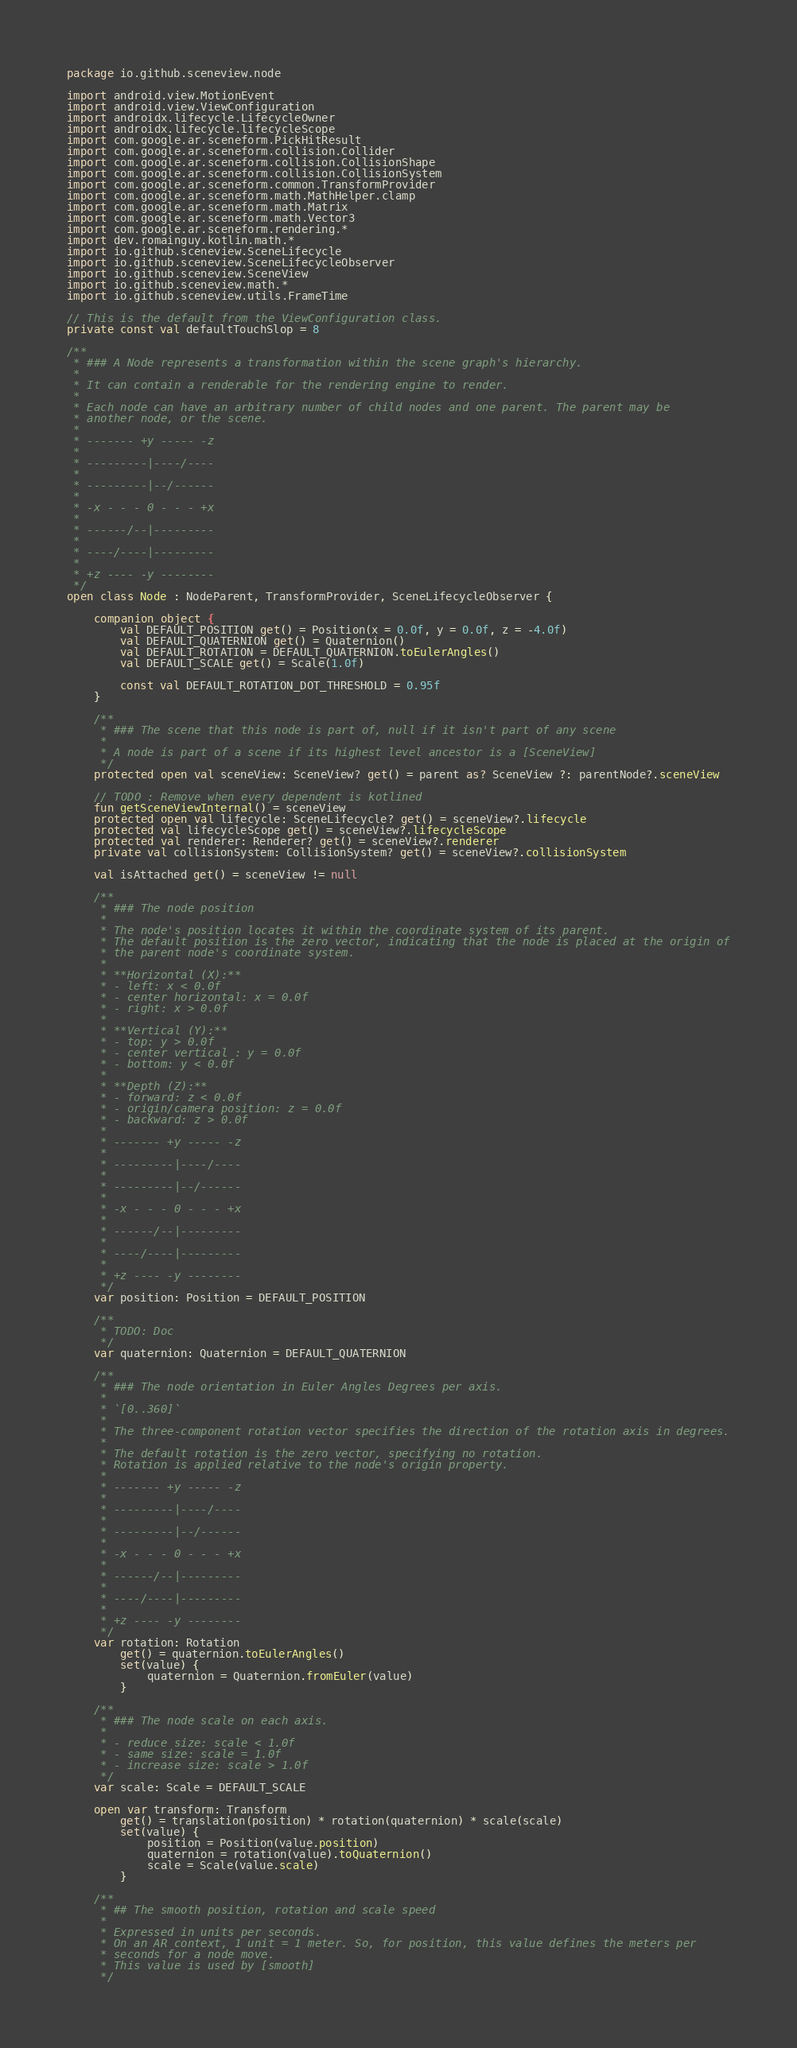Convert code to text. <code><loc_0><loc_0><loc_500><loc_500><_Kotlin_>package io.github.sceneview.node

import android.view.MotionEvent
import android.view.ViewConfiguration
import androidx.lifecycle.LifecycleOwner
import androidx.lifecycle.lifecycleScope
import com.google.ar.sceneform.PickHitResult
import com.google.ar.sceneform.collision.Collider
import com.google.ar.sceneform.collision.CollisionShape
import com.google.ar.sceneform.collision.CollisionSystem
import com.google.ar.sceneform.common.TransformProvider
import com.google.ar.sceneform.math.MathHelper.clamp
import com.google.ar.sceneform.math.Matrix
import com.google.ar.sceneform.math.Vector3
import com.google.ar.sceneform.rendering.*
import dev.romainguy.kotlin.math.*
import io.github.sceneview.SceneLifecycle
import io.github.sceneview.SceneLifecycleObserver
import io.github.sceneview.SceneView
import io.github.sceneview.math.*
import io.github.sceneview.utils.FrameTime

// This is the default from the ViewConfiguration class.
private const val defaultTouchSlop = 8

/**
 * ### A Node represents a transformation within the scene graph's hierarchy.
 *
 * It can contain a renderable for the rendering engine to render.
 *
 * Each node can have an arbitrary number of child nodes and one parent. The parent may be
 * another node, or the scene.
 *
 * ------- +y ----- -z
 *
 * ---------|----/----
 *
 * ---------|--/------
 *
 * -x - - - 0 - - - +x
 *
 * ------/--|---------
 *
 * ----/----|---------
 *
 * +z ---- -y --------
 */
open class Node : NodeParent, TransformProvider, SceneLifecycleObserver {

    companion object {
        val DEFAULT_POSITION get() = Position(x = 0.0f, y = 0.0f, z = -4.0f)
        val DEFAULT_QUATERNION get() = Quaternion()
        val DEFAULT_ROTATION = DEFAULT_QUATERNION.toEulerAngles()
        val DEFAULT_SCALE get() = Scale(1.0f)

        const val DEFAULT_ROTATION_DOT_THRESHOLD = 0.95f
    }

    /**
     * ### The scene that this node is part of, null if it isn't part of any scene
     *
     * A node is part of a scene if its highest level ancestor is a [SceneView]
     */
    protected open val sceneView: SceneView? get() = parent as? SceneView ?: parentNode?.sceneView

    // TODO : Remove when every dependent is kotlined
    fun getSceneViewInternal() = sceneView
    protected open val lifecycle: SceneLifecycle? get() = sceneView?.lifecycle
    protected val lifecycleScope get() = sceneView?.lifecycleScope
    protected val renderer: Renderer? get() = sceneView?.renderer
    private val collisionSystem: CollisionSystem? get() = sceneView?.collisionSystem

    val isAttached get() = sceneView != null

    /**
     * ### The node position
     *
     * The node's position locates it within the coordinate system of its parent.
     * The default position is the zero vector, indicating that the node is placed at the origin of
     * the parent node's coordinate system.
     *
     * **Horizontal (X):**
     * - left: x < 0.0f
     * - center horizontal: x = 0.0f
     * - right: x > 0.0f
     *
     * **Vertical (Y):**
     * - top: y > 0.0f
     * - center vertical : y = 0.0f
     * - bottom: y < 0.0f
     *
     * **Depth (Z):**
     * - forward: z < 0.0f
     * - origin/camera position: z = 0.0f
     * - backward: z > 0.0f
     *
     * ------- +y ----- -z
     *
     * ---------|----/----
     *
     * ---------|--/------
     *
     * -x - - - 0 - - - +x
     *
     * ------/--|---------
     *
     * ----/----|---------
     *
     * +z ---- -y --------
     */
    var position: Position = DEFAULT_POSITION

    /**
     * TODO: Doc
     */
    var quaternion: Quaternion = DEFAULT_QUATERNION

    /**
     * ### The node orientation in Euler Angles Degrees per axis.
     *
     * `[0..360]`
     *
     * The three-component rotation vector specifies the direction of the rotation axis in degrees.
     *
     * The default rotation is the zero vector, specifying no rotation.
     * Rotation is applied relative to the node's origin property.
     *
     * ------- +y ----- -z
     *
     * ---------|----/----
     *
     * ---------|--/------
     *
     * -x - - - 0 - - - +x
     *
     * ------/--|---------
     *
     * ----/----|---------
     *
     * +z ---- -y --------
     */
    var rotation: Rotation
        get() = quaternion.toEulerAngles()
        set(value) {
            quaternion = Quaternion.fromEuler(value)
        }

    /**
     * ### The node scale on each axis.
     *
     * - reduce size: scale < 1.0f
     * - same size: scale = 1.0f
     * - increase size: scale > 1.0f
     */
    var scale: Scale = DEFAULT_SCALE

    open var transform: Transform
        get() = translation(position) * rotation(quaternion) * scale(scale)
        set(value) {
            position = Position(value.position)
            quaternion = rotation(value).toQuaternion()
            scale = Scale(value.scale)
        }

    /**
     * ## The smooth position, rotation and scale speed
     *
     * Expressed in units per seconds.
     * On an AR context, 1 unit = 1 meter. So, for position, this value defines the meters per
     * seconds for a node move.
     * This value is used by [smooth]
     */</code> 